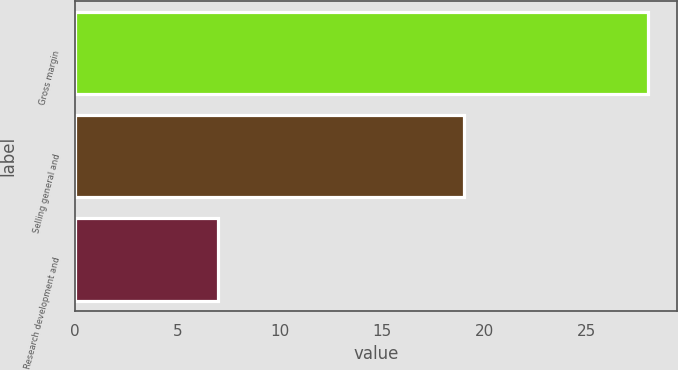<chart> <loc_0><loc_0><loc_500><loc_500><bar_chart><fcel>Gross margin<fcel>Selling general and<fcel>Research development and<nl><fcel>28<fcel>19<fcel>7<nl></chart> 